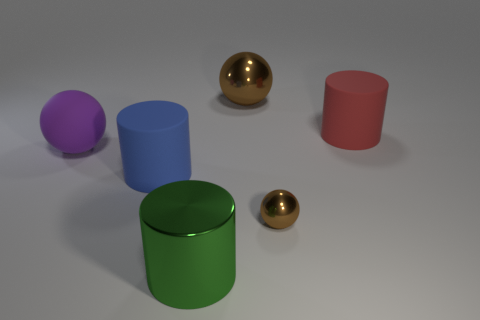Add 2 small blue things. How many objects exist? 8 Subtract all large matte balls. Subtract all gray cylinders. How many objects are left? 5 Add 5 large green metallic cylinders. How many large green metallic cylinders are left? 6 Add 1 red shiny things. How many red shiny things exist? 1 Subtract 0 green blocks. How many objects are left? 6 